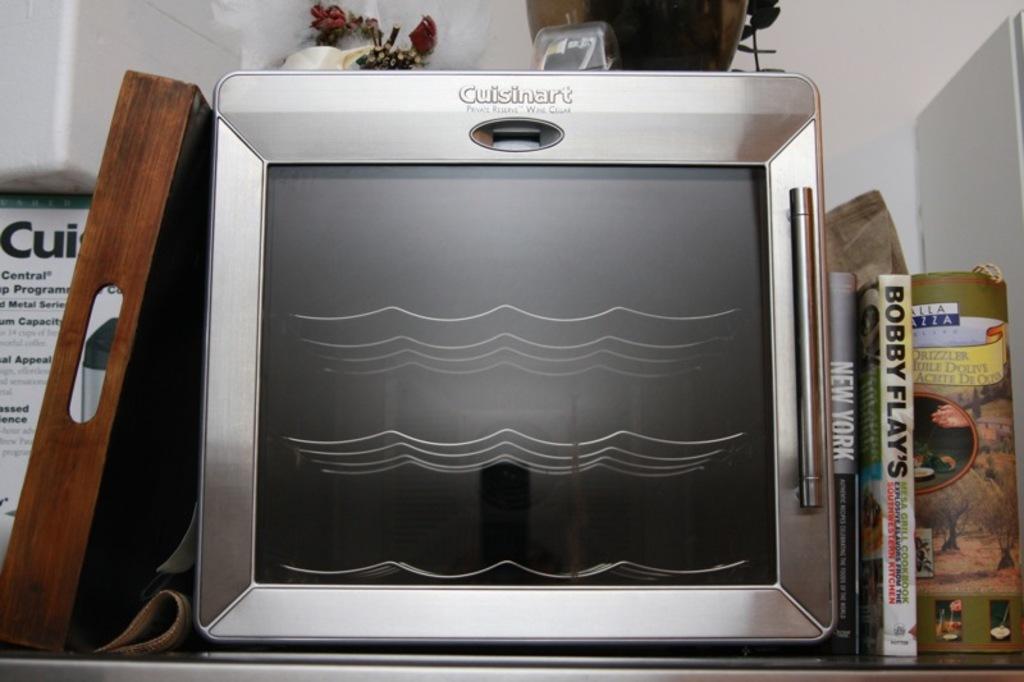What brand is this appliance?
Provide a short and direct response. Cuisinart. What is the title of the book immediately to the right of the appliance?
Give a very brief answer. New york. 